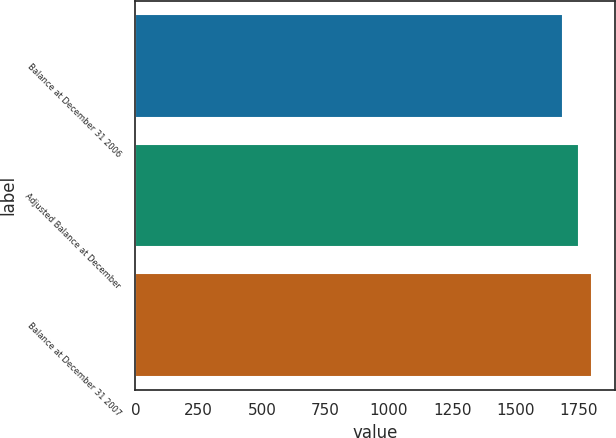<chart> <loc_0><loc_0><loc_500><loc_500><bar_chart><fcel>Balance at December 31 2006<fcel>Adjusted Balance at December<fcel>Balance at December 31 2007<nl><fcel>1689<fcel>1752<fcel>1804<nl></chart> 